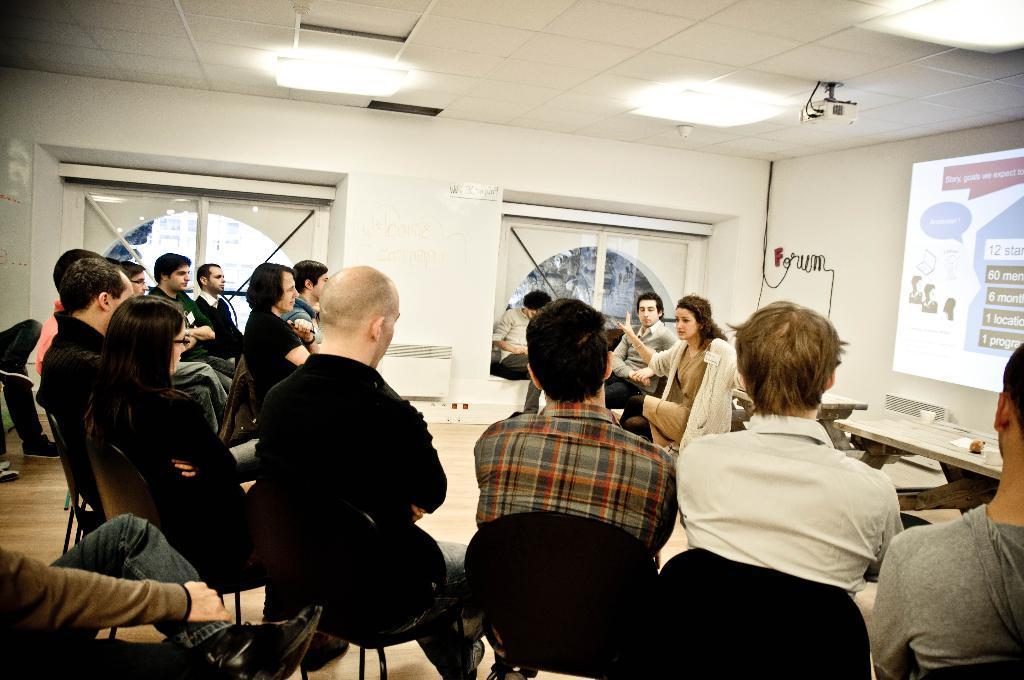How would you summarize this image in a sentence or two? In this image we can see men and women are sitting on the black chairs. In the background, we can see windows, wall, tables and screen. At the top of the image,we can see the projector and lights are attached to the roof. 